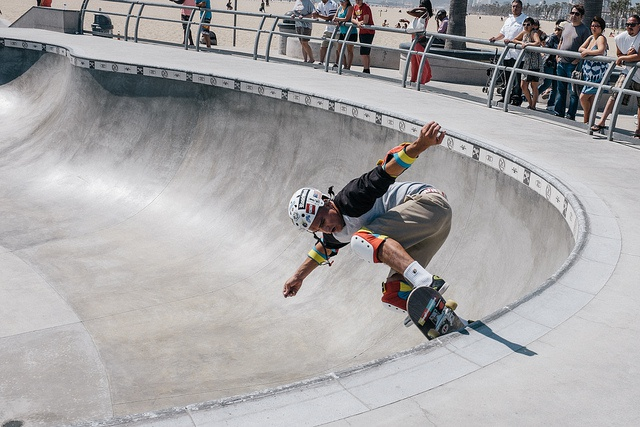Describe the objects in this image and their specific colors. I can see people in darkgray, black, gray, and maroon tones, people in darkgray, gray, black, and maroon tones, people in darkgray, black, gray, and darkblue tones, skateboard in darkgray, black, gray, and maroon tones, and people in darkgray, black, maroon, and gray tones in this image. 